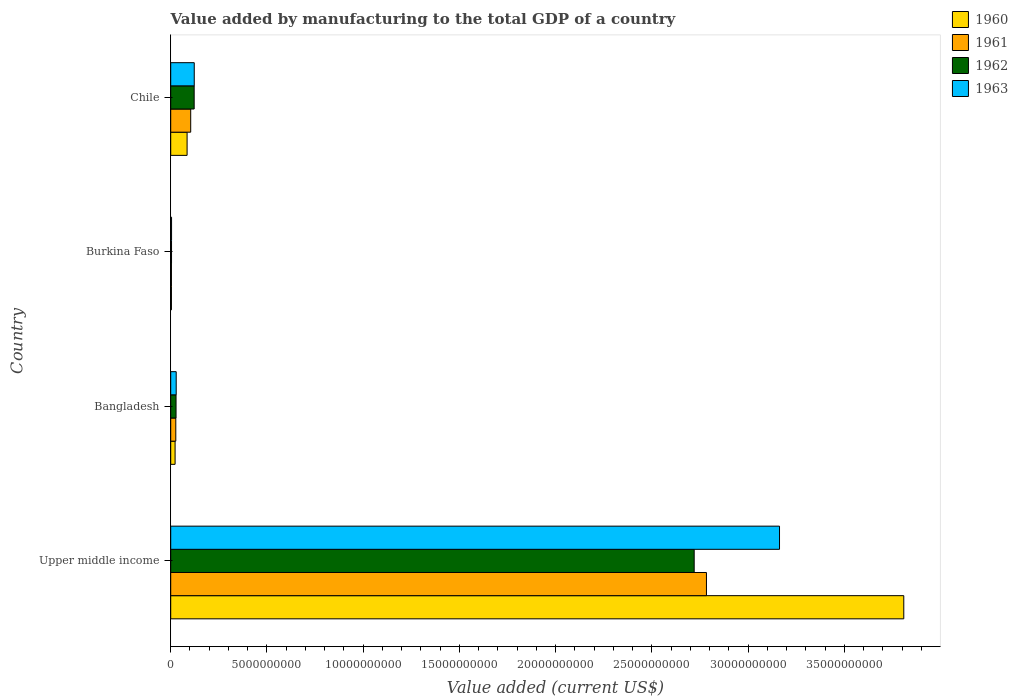How many different coloured bars are there?
Provide a short and direct response. 4. How many bars are there on the 2nd tick from the top?
Offer a very short reply. 4. What is the label of the 2nd group of bars from the top?
Offer a very short reply. Burkina Faso. In how many cases, is the number of bars for a given country not equal to the number of legend labels?
Ensure brevity in your answer.  0. What is the value added by manufacturing to the total GDP in 1961 in Burkina Faso?
Offer a terse response. 3.72e+07. Across all countries, what is the maximum value added by manufacturing to the total GDP in 1962?
Provide a succinct answer. 2.72e+1. Across all countries, what is the minimum value added by manufacturing to the total GDP in 1960?
Offer a very short reply. 3.72e+07. In which country was the value added by manufacturing to the total GDP in 1963 maximum?
Keep it short and to the point. Upper middle income. In which country was the value added by manufacturing to the total GDP in 1960 minimum?
Ensure brevity in your answer.  Burkina Faso. What is the total value added by manufacturing to the total GDP in 1960 in the graph?
Give a very brief answer. 3.92e+1. What is the difference between the value added by manufacturing to the total GDP in 1960 in Bangladesh and that in Burkina Faso?
Your response must be concise. 1.90e+08. What is the difference between the value added by manufacturing to the total GDP in 1963 in Chile and the value added by manufacturing to the total GDP in 1960 in Upper middle income?
Offer a terse response. -3.69e+1. What is the average value added by manufacturing to the total GDP in 1962 per country?
Offer a very short reply. 7.18e+09. What is the difference between the value added by manufacturing to the total GDP in 1962 and value added by manufacturing to the total GDP in 1960 in Bangladesh?
Provide a succinct answer. 4.99e+07. What is the ratio of the value added by manufacturing to the total GDP in 1961 in Bangladesh to that in Upper middle income?
Keep it short and to the point. 0.01. Is the difference between the value added by manufacturing to the total GDP in 1962 in Bangladesh and Burkina Faso greater than the difference between the value added by manufacturing to the total GDP in 1960 in Bangladesh and Burkina Faso?
Give a very brief answer. Yes. What is the difference between the highest and the second highest value added by manufacturing to the total GDP in 1962?
Keep it short and to the point. 2.60e+1. What is the difference between the highest and the lowest value added by manufacturing to the total GDP in 1963?
Offer a terse response. 3.16e+1. What does the 3rd bar from the bottom in Bangladesh represents?
Offer a terse response. 1962. How many bars are there?
Your answer should be very brief. 16. Are all the bars in the graph horizontal?
Give a very brief answer. Yes. What is the difference between two consecutive major ticks on the X-axis?
Your answer should be compact. 5.00e+09. How are the legend labels stacked?
Offer a terse response. Vertical. What is the title of the graph?
Ensure brevity in your answer.  Value added by manufacturing to the total GDP of a country. What is the label or title of the X-axis?
Your answer should be very brief. Value added (current US$). What is the Value added (current US$) of 1960 in Upper middle income?
Your answer should be very brief. 3.81e+1. What is the Value added (current US$) of 1961 in Upper middle income?
Give a very brief answer. 2.78e+1. What is the Value added (current US$) of 1962 in Upper middle income?
Ensure brevity in your answer.  2.72e+1. What is the Value added (current US$) in 1963 in Upper middle income?
Provide a succinct answer. 3.16e+1. What is the Value added (current US$) in 1960 in Bangladesh?
Provide a succinct answer. 2.27e+08. What is the Value added (current US$) in 1961 in Bangladesh?
Provide a succinct answer. 2.64e+08. What is the Value added (current US$) in 1962 in Bangladesh?
Provide a succinct answer. 2.77e+08. What is the Value added (current US$) in 1963 in Bangladesh?
Your answer should be compact. 2.85e+08. What is the Value added (current US$) in 1960 in Burkina Faso?
Offer a terse response. 3.72e+07. What is the Value added (current US$) of 1961 in Burkina Faso?
Keep it short and to the point. 3.72e+07. What is the Value added (current US$) of 1962 in Burkina Faso?
Provide a succinct answer. 4.22e+07. What is the Value added (current US$) in 1963 in Burkina Faso?
Ensure brevity in your answer.  4.39e+07. What is the Value added (current US$) of 1960 in Chile?
Your answer should be compact. 8.51e+08. What is the Value added (current US$) of 1961 in Chile?
Provide a succinct answer. 1.04e+09. What is the Value added (current US$) of 1962 in Chile?
Provide a succinct answer. 1.22e+09. What is the Value added (current US$) in 1963 in Chile?
Your answer should be very brief. 1.22e+09. Across all countries, what is the maximum Value added (current US$) in 1960?
Offer a terse response. 3.81e+1. Across all countries, what is the maximum Value added (current US$) in 1961?
Offer a very short reply. 2.78e+1. Across all countries, what is the maximum Value added (current US$) in 1962?
Offer a terse response. 2.72e+1. Across all countries, what is the maximum Value added (current US$) in 1963?
Provide a short and direct response. 3.16e+1. Across all countries, what is the minimum Value added (current US$) in 1960?
Give a very brief answer. 3.72e+07. Across all countries, what is the minimum Value added (current US$) of 1961?
Offer a very short reply. 3.72e+07. Across all countries, what is the minimum Value added (current US$) of 1962?
Ensure brevity in your answer.  4.22e+07. Across all countries, what is the minimum Value added (current US$) in 1963?
Make the answer very short. 4.39e+07. What is the total Value added (current US$) of 1960 in the graph?
Your answer should be compact. 3.92e+1. What is the total Value added (current US$) of 1961 in the graph?
Offer a very short reply. 2.92e+1. What is the total Value added (current US$) of 1962 in the graph?
Your response must be concise. 2.87e+1. What is the total Value added (current US$) in 1963 in the graph?
Ensure brevity in your answer.  3.32e+1. What is the difference between the Value added (current US$) in 1960 in Upper middle income and that in Bangladesh?
Offer a terse response. 3.79e+1. What is the difference between the Value added (current US$) in 1961 in Upper middle income and that in Bangladesh?
Keep it short and to the point. 2.76e+1. What is the difference between the Value added (current US$) of 1962 in Upper middle income and that in Bangladesh?
Offer a very short reply. 2.69e+1. What is the difference between the Value added (current US$) of 1963 in Upper middle income and that in Bangladesh?
Make the answer very short. 3.13e+1. What is the difference between the Value added (current US$) in 1960 in Upper middle income and that in Burkina Faso?
Offer a terse response. 3.81e+1. What is the difference between the Value added (current US$) in 1961 in Upper middle income and that in Burkina Faso?
Make the answer very short. 2.78e+1. What is the difference between the Value added (current US$) in 1962 in Upper middle income and that in Burkina Faso?
Provide a short and direct response. 2.72e+1. What is the difference between the Value added (current US$) of 1963 in Upper middle income and that in Burkina Faso?
Keep it short and to the point. 3.16e+1. What is the difference between the Value added (current US$) in 1960 in Upper middle income and that in Chile?
Offer a very short reply. 3.72e+1. What is the difference between the Value added (current US$) of 1961 in Upper middle income and that in Chile?
Your answer should be very brief. 2.68e+1. What is the difference between the Value added (current US$) in 1962 in Upper middle income and that in Chile?
Your answer should be very brief. 2.60e+1. What is the difference between the Value added (current US$) of 1963 in Upper middle income and that in Chile?
Offer a terse response. 3.04e+1. What is the difference between the Value added (current US$) of 1960 in Bangladesh and that in Burkina Faso?
Your response must be concise. 1.90e+08. What is the difference between the Value added (current US$) in 1961 in Bangladesh and that in Burkina Faso?
Keep it short and to the point. 2.26e+08. What is the difference between the Value added (current US$) of 1962 in Bangladesh and that in Burkina Faso?
Make the answer very short. 2.35e+08. What is the difference between the Value added (current US$) of 1963 in Bangladesh and that in Burkina Faso?
Your answer should be compact. 2.41e+08. What is the difference between the Value added (current US$) of 1960 in Bangladesh and that in Chile?
Give a very brief answer. -6.24e+08. What is the difference between the Value added (current US$) in 1961 in Bangladesh and that in Chile?
Keep it short and to the point. -7.75e+08. What is the difference between the Value added (current US$) in 1962 in Bangladesh and that in Chile?
Offer a terse response. -9.41e+08. What is the difference between the Value added (current US$) of 1963 in Bangladesh and that in Chile?
Offer a very short reply. -9.38e+08. What is the difference between the Value added (current US$) of 1960 in Burkina Faso and that in Chile?
Keep it short and to the point. -8.13e+08. What is the difference between the Value added (current US$) of 1961 in Burkina Faso and that in Chile?
Your answer should be compact. -1.00e+09. What is the difference between the Value added (current US$) of 1962 in Burkina Faso and that in Chile?
Offer a very short reply. -1.18e+09. What is the difference between the Value added (current US$) of 1963 in Burkina Faso and that in Chile?
Ensure brevity in your answer.  -1.18e+09. What is the difference between the Value added (current US$) in 1960 in Upper middle income and the Value added (current US$) in 1961 in Bangladesh?
Your answer should be very brief. 3.78e+1. What is the difference between the Value added (current US$) in 1960 in Upper middle income and the Value added (current US$) in 1962 in Bangladesh?
Keep it short and to the point. 3.78e+1. What is the difference between the Value added (current US$) of 1960 in Upper middle income and the Value added (current US$) of 1963 in Bangladesh?
Ensure brevity in your answer.  3.78e+1. What is the difference between the Value added (current US$) of 1961 in Upper middle income and the Value added (current US$) of 1962 in Bangladesh?
Your response must be concise. 2.76e+1. What is the difference between the Value added (current US$) in 1961 in Upper middle income and the Value added (current US$) in 1963 in Bangladesh?
Offer a very short reply. 2.76e+1. What is the difference between the Value added (current US$) in 1962 in Upper middle income and the Value added (current US$) in 1963 in Bangladesh?
Your answer should be compact. 2.69e+1. What is the difference between the Value added (current US$) of 1960 in Upper middle income and the Value added (current US$) of 1961 in Burkina Faso?
Your answer should be compact. 3.81e+1. What is the difference between the Value added (current US$) in 1960 in Upper middle income and the Value added (current US$) in 1962 in Burkina Faso?
Your response must be concise. 3.80e+1. What is the difference between the Value added (current US$) in 1960 in Upper middle income and the Value added (current US$) in 1963 in Burkina Faso?
Provide a short and direct response. 3.80e+1. What is the difference between the Value added (current US$) in 1961 in Upper middle income and the Value added (current US$) in 1962 in Burkina Faso?
Your response must be concise. 2.78e+1. What is the difference between the Value added (current US$) in 1961 in Upper middle income and the Value added (current US$) in 1963 in Burkina Faso?
Offer a terse response. 2.78e+1. What is the difference between the Value added (current US$) in 1962 in Upper middle income and the Value added (current US$) in 1963 in Burkina Faso?
Provide a short and direct response. 2.72e+1. What is the difference between the Value added (current US$) in 1960 in Upper middle income and the Value added (current US$) in 1961 in Chile?
Your answer should be compact. 3.71e+1. What is the difference between the Value added (current US$) of 1960 in Upper middle income and the Value added (current US$) of 1962 in Chile?
Your response must be concise. 3.69e+1. What is the difference between the Value added (current US$) in 1960 in Upper middle income and the Value added (current US$) in 1963 in Chile?
Your response must be concise. 3.69e+1. What is the difference between the Value added (current US$) in 1961 in Upper middle income and the Value added (current US$) in 1962 in Chile?
Provide a short and direct response. 2.66e+1. What is the difference between the Value added (current US$) of 1961 in Upper middle income and the Value added (current US$) of 1963 in Chile?
Ensure brevity in your answer.  2.66e+1. What is the difference between the Value added (current US$) of 1962 in Upper middle income and the Value added (current US$) of 1963 in Chile?
Offer a very short reply. 2.60e+1. What is the difference between the Value added (current US$) in 1960 in Bangladesh and the Value added (current US$) in 1961 in Burkina Faso?
Your answer should be very brief. 1.90e+08. What is the difference between the Value added (current US$) in 1960 in Bangladesh and the Value added (current US$) in 1962 in Burkina Faso?
Your answer should be very brief. 1.85e+08. What is the difference between the Value added (current US$) of 1960 in Bangladesh and the Value added (current US$) of 1963 in Burkina Faso?
Offer a very short reply. 1.83e+08. What is the difference between the Value added (current US$) in 1961 in Bangladesh and the Value added (current US$) in 1962 in Burkina Faso?
Provide a succinct answer. 2.21e+08. What is the difference between the Value added (current US$) of 1961 in Bangladesh and the Value added (current US$) of 1963 in Burkina Faso?
Provide a short and direct response. 2.20e+08. What is the difference between the Value added (current US$) in 1962 in Bangladesh and the Value added (current US$) in 1963 in Burkina Faso?
Make the answer very short. 2.33e+08. What is the difference between the Value added (current US$) in 1960 in Bangladesh and the Value added (current US$) in 1961 in Chile?
Provide a succinct answer. -8.12e+08. What is the difference between the Value added (current US$) of 1960 in Bangladesh and the Value added (current US$) of 1962 in Chile?
Make the answer very short. -9.91e+08. What is the difference between the Value added (current US$) in 1960 in Bangladesh and the Value added (current US$) in 1963 in Chile?
Offer a very short reply. -9.96e+08. What is the difference between the Value added (current US$) in 1961 in Bangladesh and the Value added (current US$) in 1962 in Chile?
Ensure brevity in your answer.  -9.55e+08. What is the difference between the Value added (current US$) in 1961 in Bangladesh and the Value added (current US$) in 1963 in Chile?
Make the answer very short. -9.59e+08. What is the difference between the Value added (current US$) in 1962 in Bangladesh and the Value added (current US$) in 1963 in Chile?
Offer a terse response. -9.46e+08. What is the difference between the Value added (current US$) in 1960 in Burkina Faso and the Value added (current US$) in 1961 in Chile?
Give a very brief answer. -1.00e+09. What is the difference between the Value added (current US$) of 1960 in Burkina Faso and the Value added (current US$) of 1962 in Chile?
Your response must be concise. -1.18e+09. What is the difference between the Value added (current US$) in 1960 in Burkina Faso and the Value added (current US$) in 1963 in Chile?
Give a very brief answer. -1.19e+09. What is the difference between the Value added (current US$) in 1961 in Burkina Faso and the Value added (current US$) in 1962 in Chile?
Make the answer very short. -1.18e+09. What is the difference between the Value added (current US$) in 1961 in Burkina Faso and the Value added (current US$) in 1963 in Chile?
Make the answer very short. -1.19e+09. What is the difference between the Value added (current US$) of 1962 in Burkina Faso and the Value added (current US$) of 1963 in Chile?
Offer a very short reply. -1.18e+09. What is the average Value added (current US$) of 1960 per country?
Your answer should be very brief. 9.80e+09. What is the average Value added (current US$) in 1961 per country?
Your answer should be compact. 7.29e+09. What is the average Value added (current US$) in 1962 per country?
Offer a terse response. 7.18e+09. What is the average Value added (current US$) in 1963 per country?
Provide a succinct answer. 8.30e+09. What is the difference between the Value added (current US$) in 1960 and Value added (current US$) in 1961 in Upper middle income?
Make the answer very short. 1.03e+1. What is the difference between the Value added (current US$) of 1960 and Value added (current US$) of 1962 in Upper middle income?
Offer a terse response. 1.09e+1. What is the difference between the Value added (current US$) of 1960 and Value added (current US$) of 1963 in Upper middle income?
Your answer should be very brief. 6.46e+09. What is the difference between the Value added (current US$) of 1961 and Value added (current US$) of 1962 in Upper middle income?
Ensure brevity in your answer.  6.38e+08. What is the difference between the Value added (current US$) of 1961 and Value added (current US$) of 1963 in Upper middle income?
Your answer should be very brief. -3.80e+09. What is the difference between the Value added (current US$) of 1962 and Value added (current US$) of 1963 in Upper middle income?
Your answer should be compact. -4.43e+09. What is the difference between the Value added (current US$) in 1960 and Value added (current US$) in 1961 in Bangladesh?
Ensure brevity in your answer.  -3.66e+07. What is the difference between the Value added (current US$) of 1960 and Value added (current US$) of 1962 in Bangladesh?
Your response must be concise. -4.99e+07. What is the difference between the Value added (current US$) of 1960 and Value added (current US$) of 1963 in Bangladesh?
Your response must be concise. -5.81e+07. What is the difference between the Value added (current US$) of 1961 and Value added (current US$) of 1962 in Bangladesh?
Provide a succinct answer. -1.33e+07. What is the difference between the Value added (current US$) of 1961 and Value added (current US$) of 1963 in Bangladesh?
Offer a terse response. -2.15e+07. What is the difference between the Value added (current US$) in 1962 and Value added (current US$) in 1963 in Bangladesh?
Your answer should be very brief. -8.22e+06. What is the difference between the Value added (current US$) of 1960 and Value added (current US$) of 1961 in Burkina Faso?
Give a very brief answer. 9866.11. What is the difference between the Value added (current US$) of 1960 and Value added (current US$) of 1962 in Burkina Faso?
Your answer should be very brief. -5.00e+06. What is the difference between the Value added (current US$) in 1960 and Value added (current US$) in 1963 in Burkina Faso?
Provide a succinct answer. -6.65e+06. What is the difference between the Value added (current US$) in 1961 and Value added (current US$) in 1962 in Burkina Faso?
Ensure brevity in your answer.  -5.01e+06. What is the difference between the Value added (current US$) in 1961 and Value added (current US$) in 1963 in Burkina Faso?
Keep it short and to the point. -6.66e+06. What is the difference between the Value added (current US$) in 1962 and Value added (current US$) in 1963 in Burkina Faso?
Ensure brevity in your answer.  -1.65e+06. What is the difference between the Value added (current US$) of 1960 and Value added (current US$) of 1961 in Chile?
Give a very brief answer. -1.88e+08. What is the difference between the Value added (current US$) in 1960 and Value added (current US$) in 1962 in Chile?
Make the answer very short. -3.68e+08. What is the difference between the Value added (current US$) in 1960 and Value added (current US$) in 1963 in Chile?
Your answer should be compact. -3.72e+08. What is the difference between the Value added (current US$) in 1961 and Value added (current US$) in 1962 in Chile?
Keep it short and to the point. -1.80e+08. What is the difference between the Value added (current US$) in 1961 and Value added (current US$) in 1963 in Chile?
Your answer should be compact. -1.84e+08. What is the difference between the Value added (current US$) of 1962 and Value added (current US$) of 1963 in Chile?
Offer a terse response. -4.28e+06. What is the ratio of the Value added (current US$) of 1960 in Upper middle income to that in Bangladesh?
Your answer should be very brief. 167.8. What is the ratio of the Value added (current US$) of 1961 in Upper middle income to that in Bangladesh?
Your answer should be very brief. 105.62. What is the ratio of the Value added (current US$) in 1962 in Upper middle income to that in Bangladesh?
Your response must be concise. 98.24. What is the ratio of the Value added (current US$) of 1963 in Upper middle income to that in Bangladesh?
Keep it short and to the point. 110.96. What is the ratio of the Value added (current US$) in 1960 in Upper middle income to that in Burkina Faso?
Provide a short and direct response. 1023.17. What is the ratio of the Value added (current US$) in 1961 in Upper middle income to that in Burkina Faso?
Your answer should be compact. 747.95. What is the ratio of the Value added (current US$) in 1962 in Upper middle income to that in Burkina Faso?
Ensure brevity in your answer.  644.09. What is the ratio of the Value added (current US$) of 1963 in Upper middle income to that in Burkina Faso?
Keep it short and to the point. 720.87. What is the ratio of the Value added (current US$) of 1960 in Upper middle income to that in Chile?
Your answer should be very brief. 44.77. What is the ratio of the Value added (current US$) in 1961 in Upper middle income to that in Chile?
Offer a very short reply. 26.8. What is the ratio of the Value added (current US$) in 1962 in Upper middle income to that in Chile?
Provide a succinct answer. 22.32. What is the ratio of the Value added (current US$) of 1963 in Upper middle income to that in Chile?
Your response must be concise. 25.87. What is the ratio of the Value added (current US$) of 1960 in Bangladesh to that in Burkina Faso?
Make the answer very short. 6.1. What is the ratio of the Value added (current US$) of 1961 in Bangladesh to that in Burkina Faso?
Your answer should be very brief. 7.08. What is the ratio of the Value added (current US$) in 1962 in Bangladesh to that in Burkina Faso?
Make the answer very short. 6.56. What is the ratio of the Value added (current US$) in 1963 in Bangladesh to that in Burkina Faso?
Provide a short and direct response. 6.5. What is the ratio of the Value added (current US$) in 1960 in Bangladesh to that in Chile?
Provide a short and direct response. 0.27. What is the ratio of the Value added (current US$) in 1961 in Bangladesh to that in Chile?
Provide a succinct answer. 0.25. What is the ratio of the Value added (current US$) in 1962 in Bangladesh to that in Chile?
Make the answer very short. 0.23. What is the ratio of the Value added (current US$) in 1963 in Bangladesh to that in Chile?
Keep it short and to the point. 0.23. What is the ratio of the Value added (current US$) of 1960 in Burkina Faso to that in Chile?
Make the answer very short. 0.04. What is the ratio of the Value added (current US$) in 1961 in Burkina Faso to that in Chile?
Your response must be concise. 0.04. What is the ratio of the Value added (current US$) of 1962 in Burkina Faso to that in Chile?
Your answer should be compact. 0.03. What is the ratio of the Value added (current US$) in 1963 in Burkina Faso to that in Chile?
Offer a very short reply. 0.04. What is the difference between the highest and the second highest Value added (current US$) of 1960?
Your answer should be compact. 3.72e+1. What is the difference between the highest and the second highest Value added (current US$) of 1961?
Ensure brevity in your answer.  2.68e+1. What is the difference between the highest and the second highest Value added (current US$) in 1962?
Your answer should be very brief. 2.60e+1. What is the difference between the highest and the second highest Value added (current US$) of 1963?
Your answer should be very brief. 3.04e+1. What is the difference between the highest and the lowest Value added (current US$) in 1960?
Offer a very short reply. 3.81e+1. What is the difference between the highest and the lowest Value added (current US$) in 1961?
Provide a short and direct response. 2.78e+1. What is the difference between the highest and the lowest Value added (current US$) in 1962?
Your response must be concise. 2.72e+1. What is the difference between the highest and the lowest Value added (current US$) in 1963?
Your answer should be compact. 3.16e+1. 